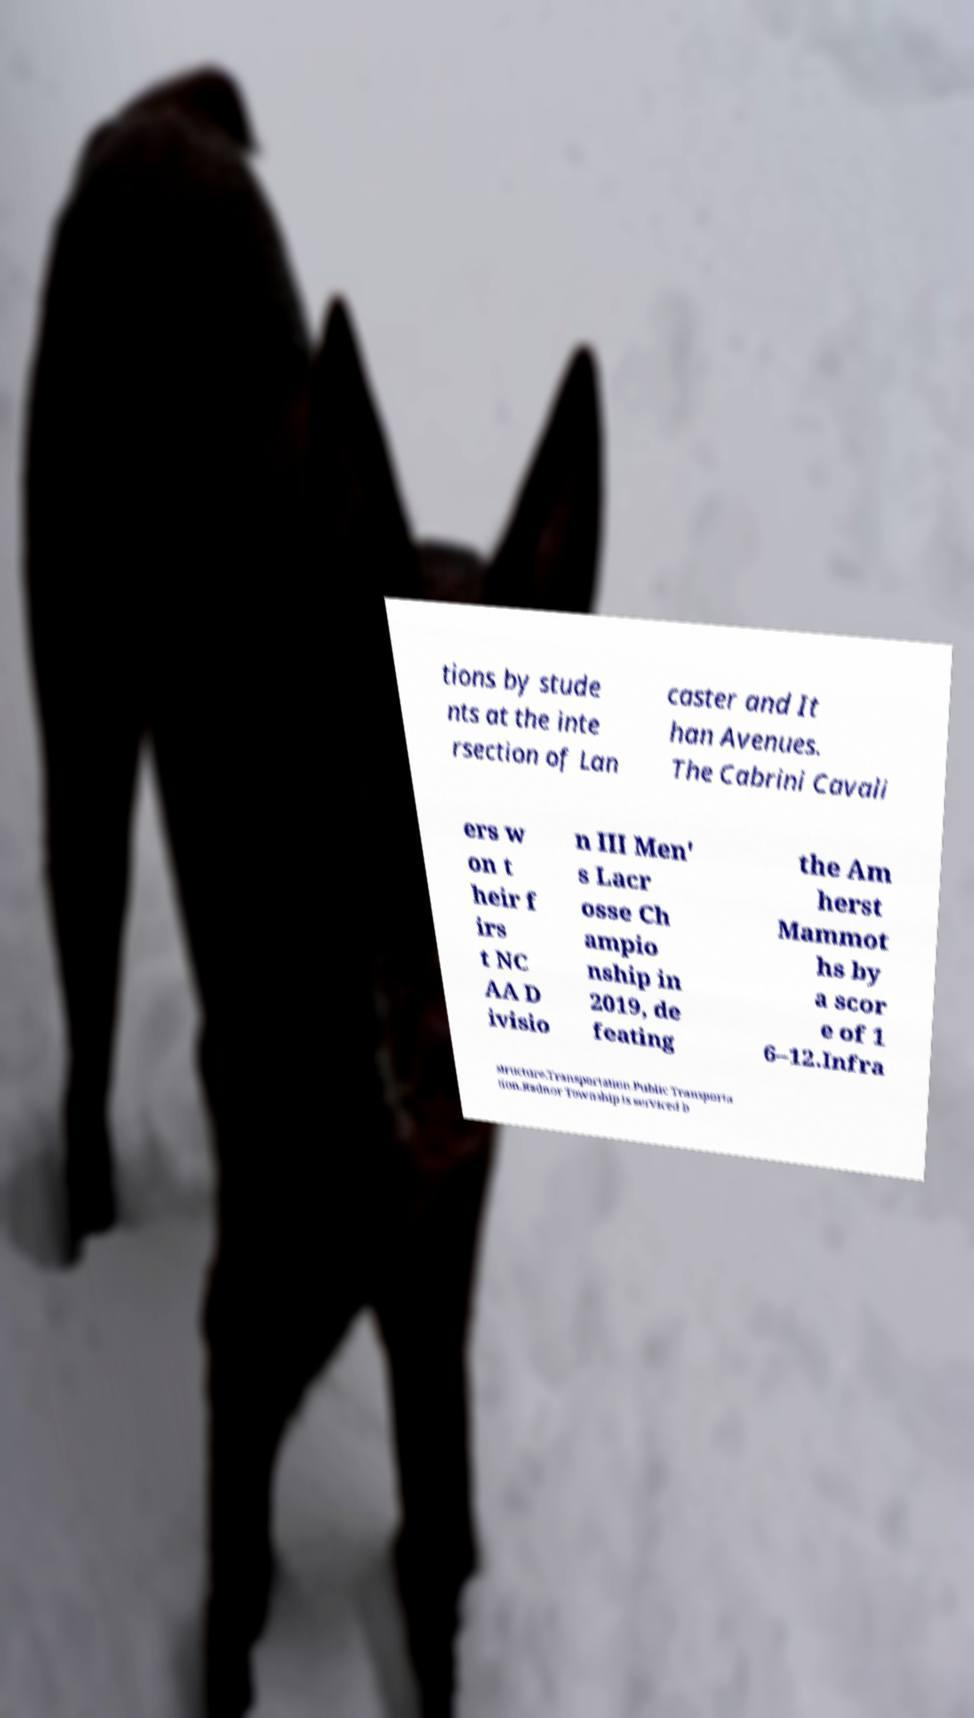There's text embedded in this image that I need extracted. Can you transcribe it verbatim? tions by stude nts at the inte rsection of Lan caster and It han Avenues. The Cabrini Cavali ers w on t heir f irs t NC AA D ivisio n III Men' s Lacr osse Ch ampio nship in 2019, de feating the Am herst Mammot hs by a scor e of 1 6–12.Infra structure.Transportation.Public Transporta tion.Radnor Township is serviced b 